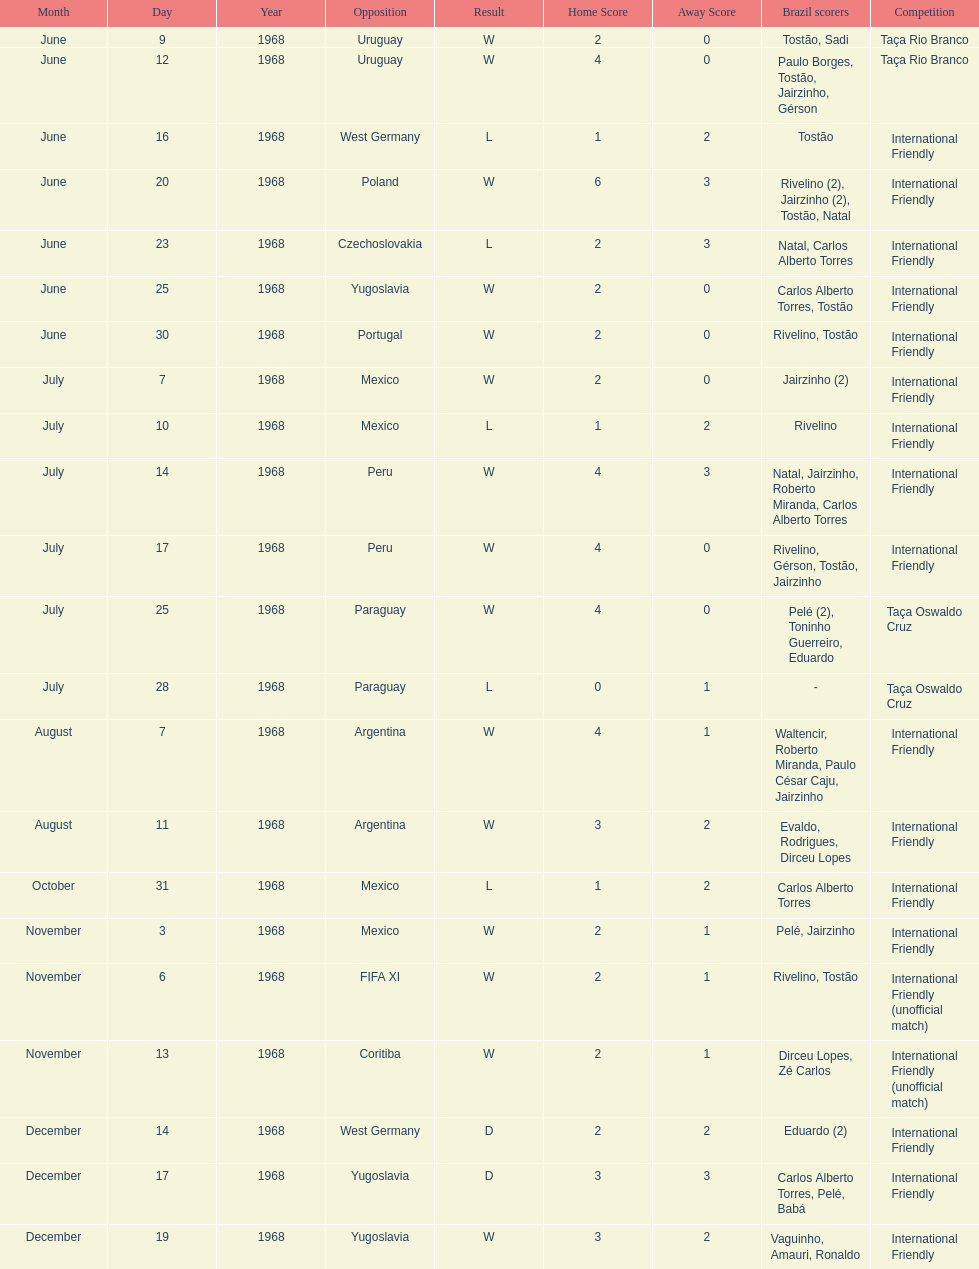What year has the highest scoring game? 1968. 